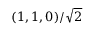<formula> <loc_0><loc_0><loc_500><loc_500>( 1 , 1 , 0 ) / \sqrt { 2 }</formula> 